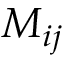<formula> <loc_0><loc_0><loc_500><loc_500>M _ { i j }</formula> 